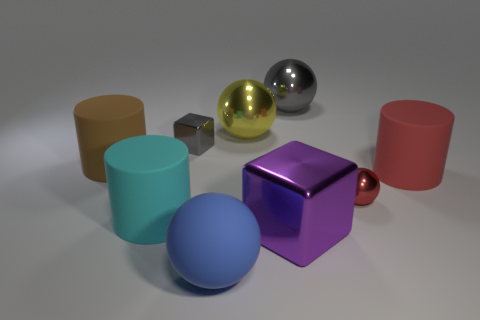How many cyan objects are big balls or small blocks?
Offer a terse response. 0. There is a small object that is right of the big blue sphere; what number of blue things are in front of it?
Make the answer very short. 1. Are there any other things of the same color as the matte ball?
Offer a terse response. No. What shape is the small gray thing that is made of the same material as the purple block?
Offer a terse response. Cube. Is the cylinder that is right of the large blue matte thing made of the same material as the tiny thing in front of the brown cylinder?
Make the answer very short. No. What number of objects are either large red rubber things or large cylinders that are in front of the big brown cylinder?
Offer a terse response. 2. What shape is the large object that is the same color as the small block?
Make the answer very short. Sphere. What is the big purple cube made of?
Offer a terse response. Metal. Do the small gray block and the large purple block have the same material?
Provide a succinct answer. Yes. What number of rubber things are either cyan objects or tiny blue cylinders?
Provide a succinct answer. 1. 